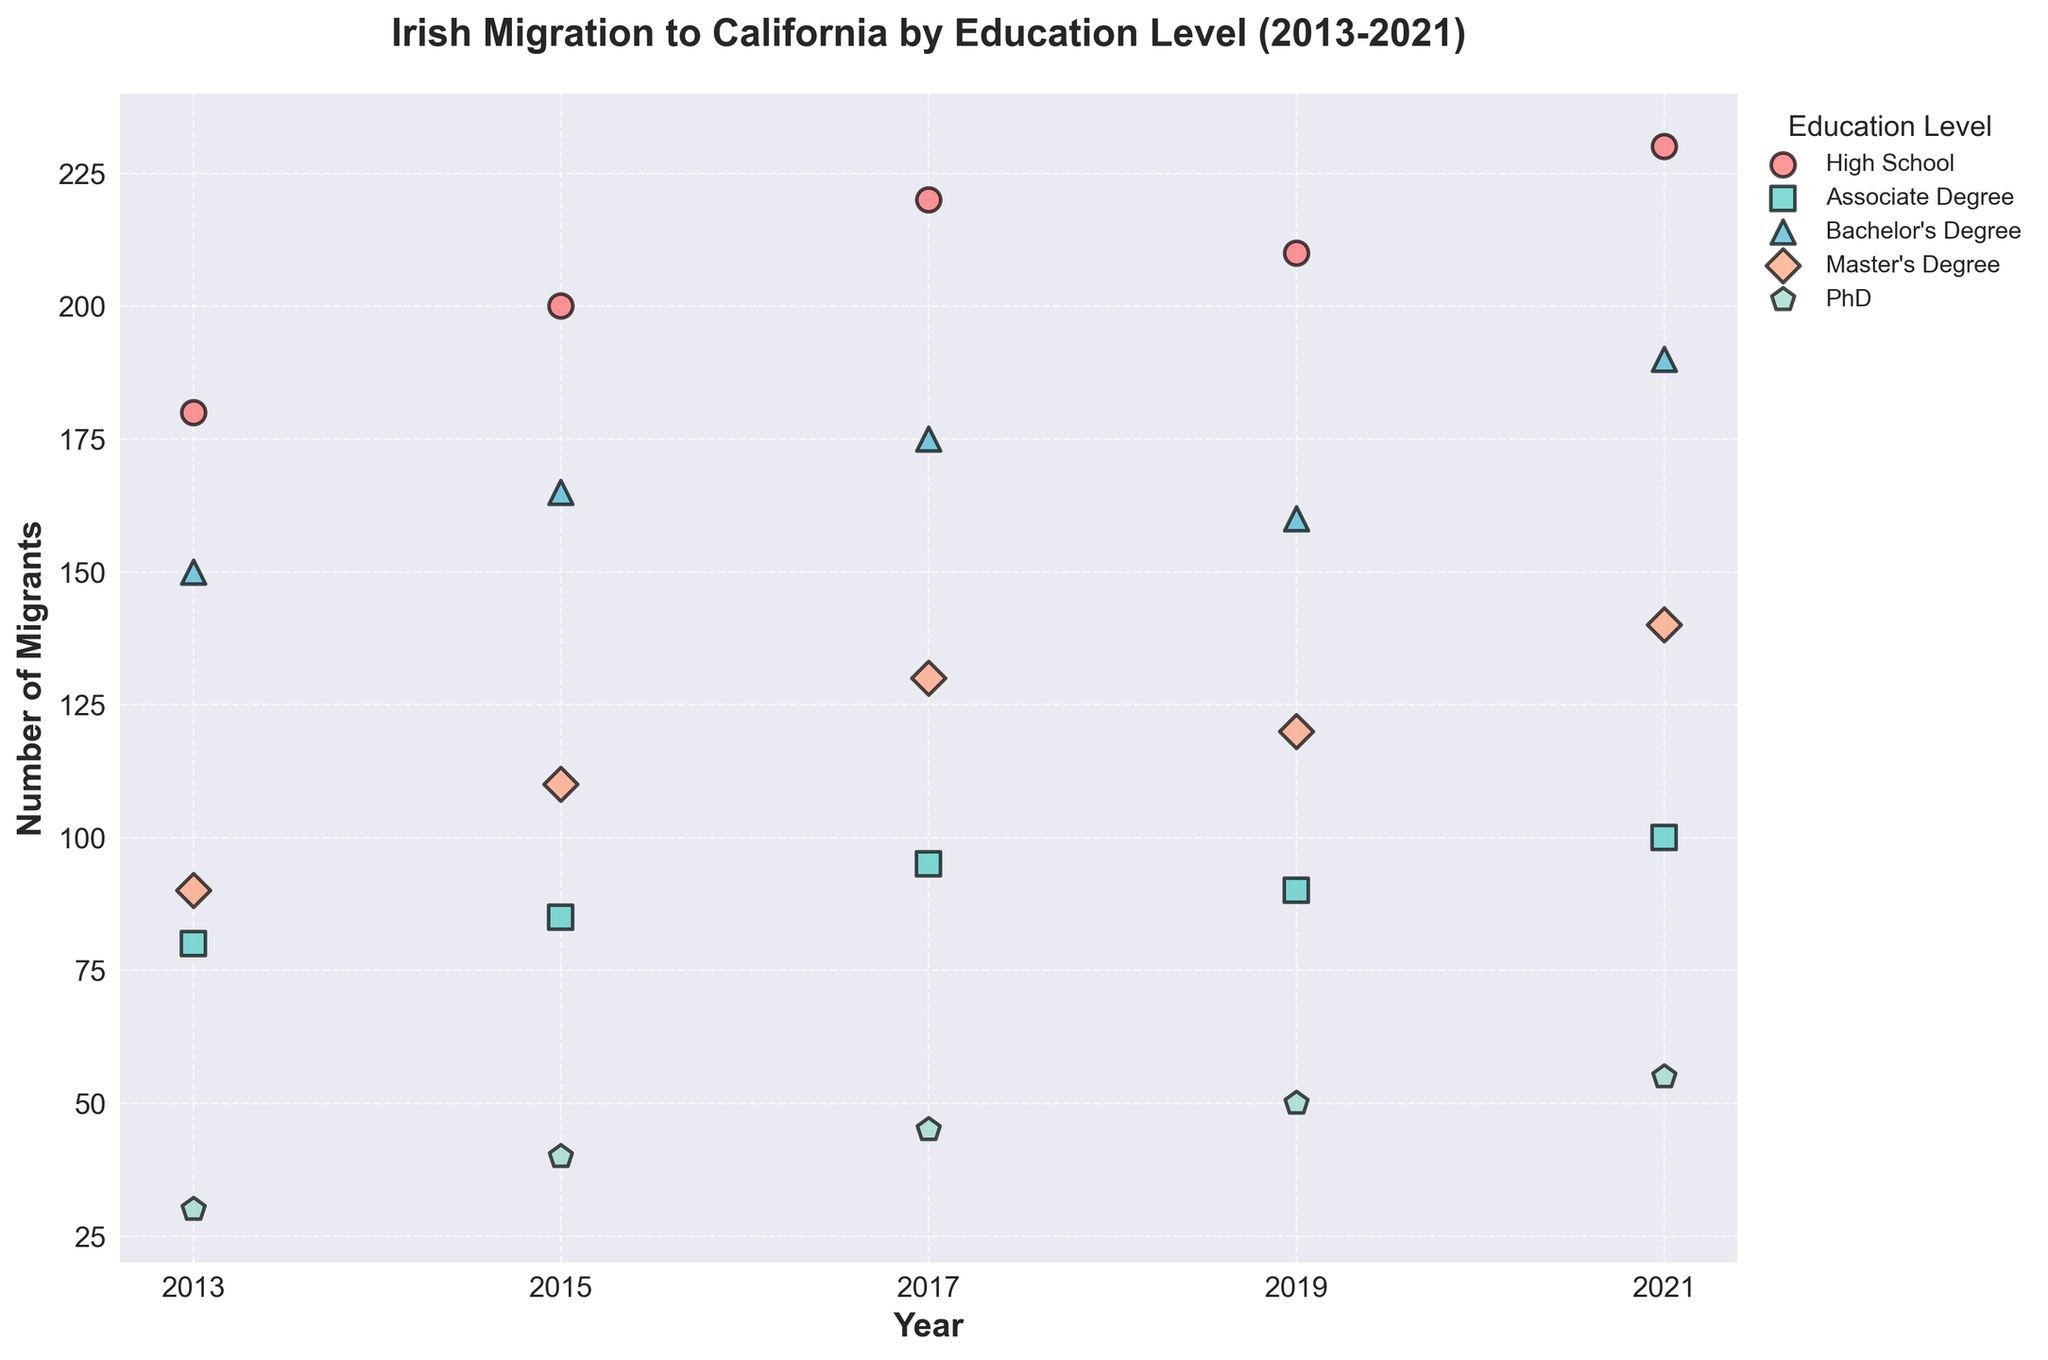What is the title of the plot? The title of the plot can be found at the top of the figure, which is usually in a larger and bold font to stand out. The title is "Irish Migration to California by Education Level (2013-2021)".
Answer: Irish Migration to California by Education Level (2013-2021) How many different education levels are represented in the plot? By looking at the legend on the plot, we can see that there are five different education levels represented: High School, Associate Degree, Bachelor's Degree, Master's Degree, and PhD.
Answer: 5 Which education level saw the highest number of migrants in 2021? We observe the data points marked with different colors and shapes for the year 2021. The highest number of migrants is associated with the "High School" education level, as its data point is the highest on the y-axis.
Answer: High School What is the trend in the number of migrants with a Bachelor's Degree from 2013 to 2021? Tracking the data points for the Bachelor's Degree over the years 2013, 2015, 2017, 2019, and 2021, we notice an increasing trend. The number of migrants with a Bachelor's Degree increases gradually over these years.
Answer: Increasing In which year did the number of Master's Degree migrants nearly double compared to the first recorded year, 2013? In 2013, the number of Master's Degree migrants was 90. Looking at the data points for subsequent years, we find that by 2021, the number nearly doubled to 140. 2021 is the year when the number of Master's Degree migrants almost doubled compared to 2013.
Answer: 2021 Compare the number of PhD migrants in 2013 and 2021. Did it increase or decrease? Analyzing the scatter points for PhD migrants in 2013 and 2021, we see the count was 30 in 2013 and increased to 55 in 2021. Therefore, the number of PhD migrants increased over this period.
Answer: Increased Which education level had the least number of migrants in all years? By examining all the data points on the plot across different education levels, it is clear that "PhD" consistently has the lowest number of migrants each year.
Answer: PhD Calculate the total number of High School migrants from 2013 to 2021. Summing up the number of High School migrants for the years 2013, 2015, 2017, 2019, and 2021: 180 + 200 + 220 + 210 + 230 = 1040.
Answer: 1040 Between 2015 and 2017, which education level saw the highest increase in the number of migrants? To find which education level saw the highest increase, we calculate the difference between the counts in 2015 and 2017 for each level: High School (220-200=20), Associate Degree (95-85=10), Bachelor's Degree (175-165=10), Master's Degree (130-110=20), PhD (45-40=5). Both High School and Master's Degree saw the highest increase, which is 20.
Answer: High School and Master's Degree 